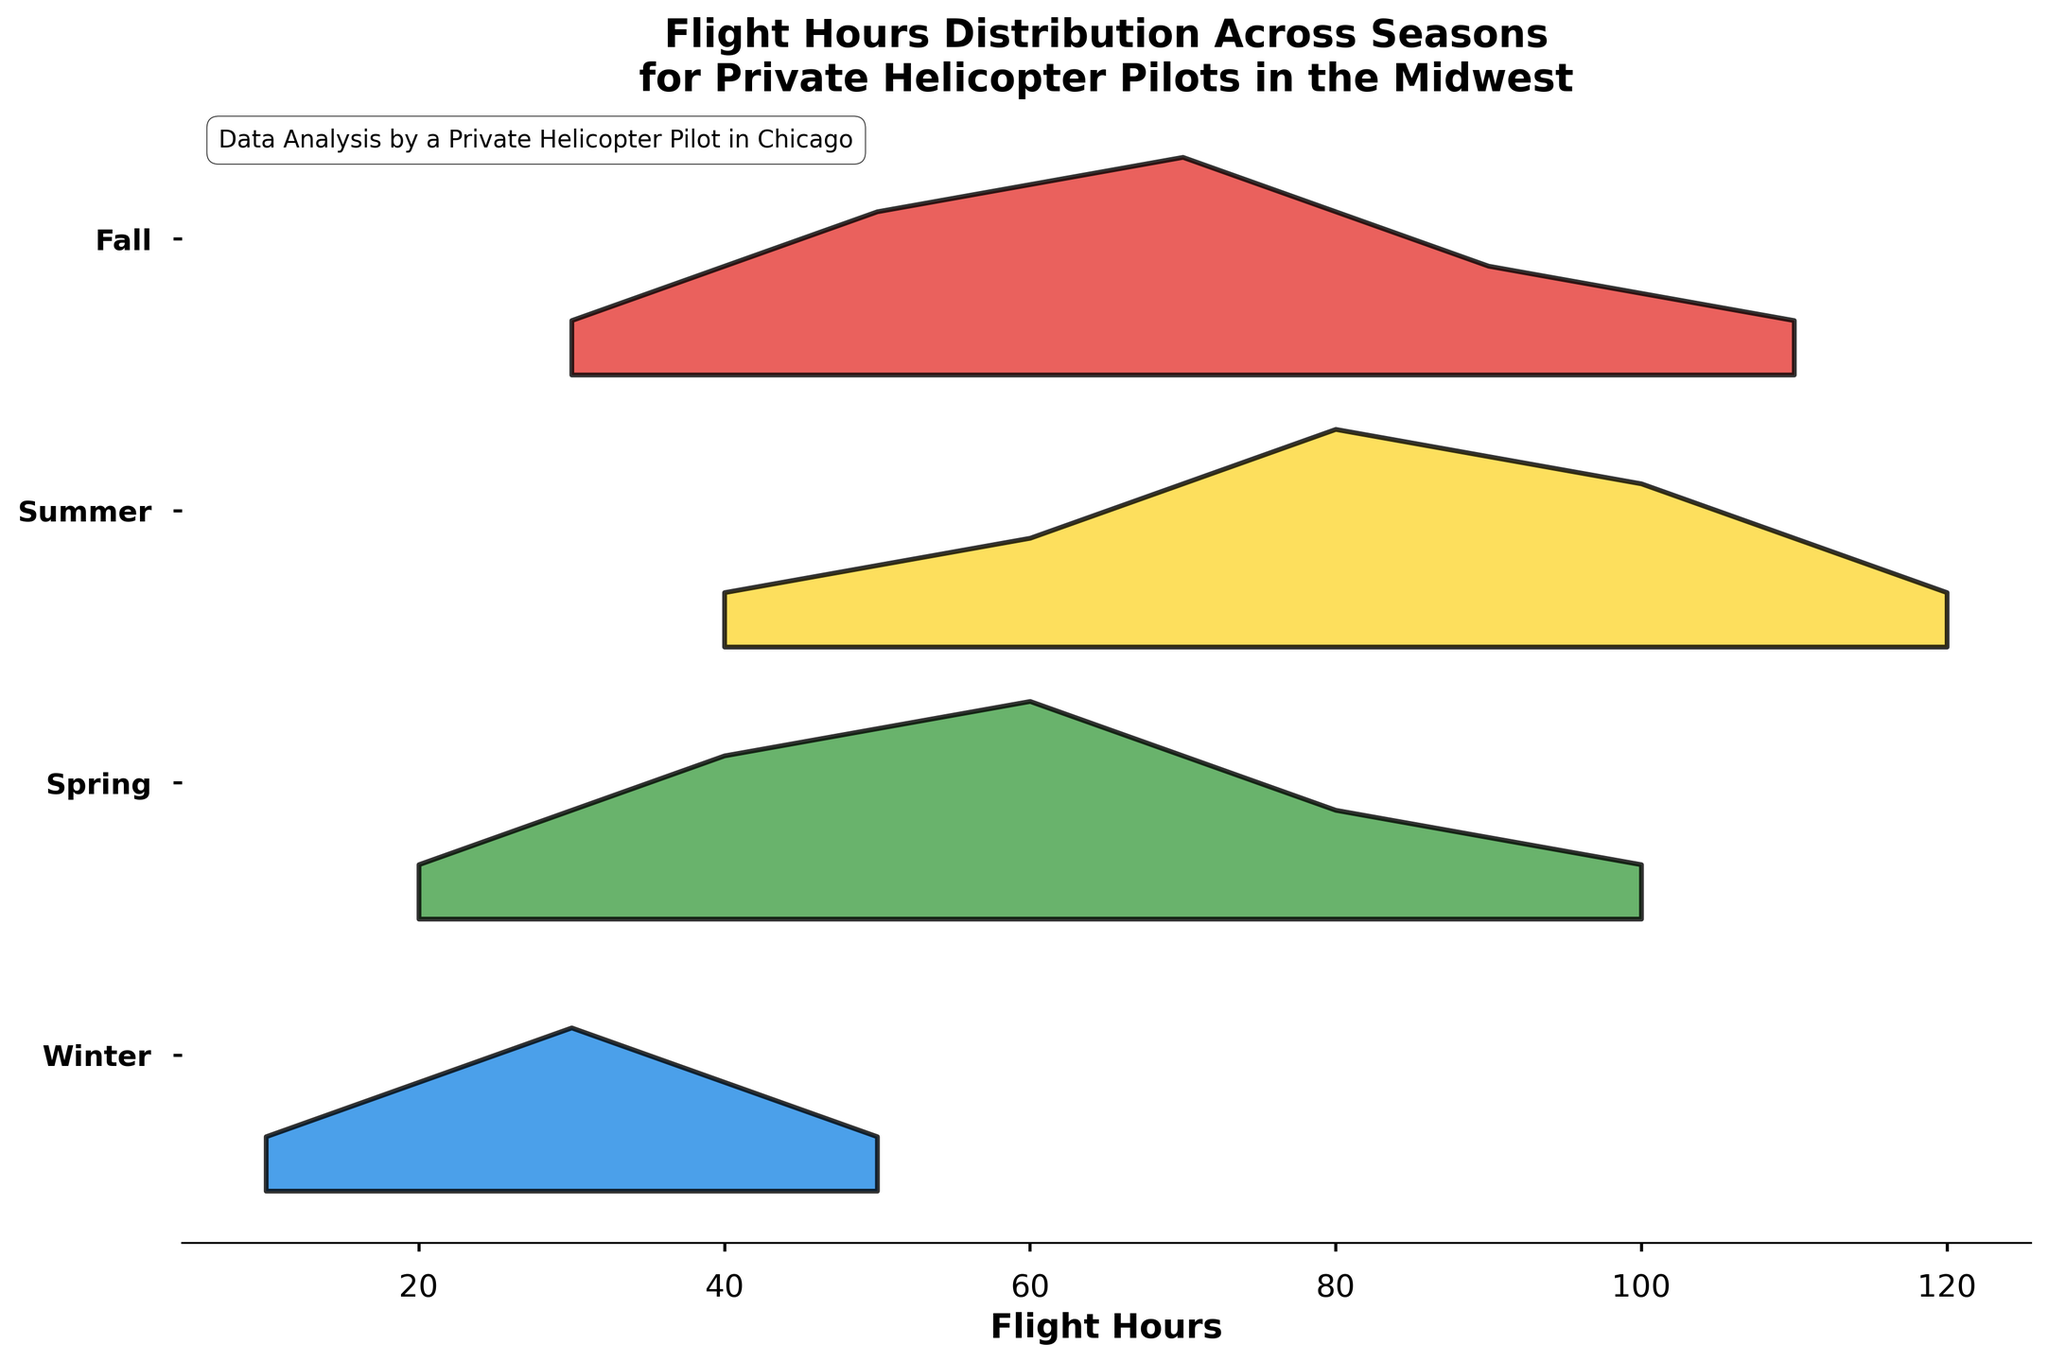What is the title of the figure? The title can be found at the top of the figure, specifying the context and subject of the data displayed.
Answer: Flight Hours Distribution Across Seasons for Private Helicopter Pilots in the Midwest Which season shows the highest density of flight hours around 80? Look at the height of the density curve around the 80-hour mark for each season.
Answer: Summer How many seasons are represented in the plot? Count the number of unique seasons represented on the y-axis.
Answer: 4 During which season do pilots have the lowest flight hours density? Identify the season with the lowest peak density by comparing the heights of the density curves across all seasons.
Answer: Winter What is the range of flight hours displayed in the figure? Check the x-axis to determine the minimum and maximum flight hours shown in the figure.
Answer: 10 to 120 In which season are the flight hours most evenly distributed from 20 to 100 hours? Compare the spread and flatness of the density curves across the seasons within that hour range.
Answer: Spring What's the highest density value for Fall season? Look at the peak of the density curve for Fall to find its highest point on the y-axis.
Answer: 0.04 Compare the density of flight hours at 50 hours between Winter and Fall. Which season shows a higher density? Compare the density values at 50 hours for Winter and Fall by examining the height of the curves at that point.
Answer: Fall Which season has the broadest range of flight hours with notable density? Identify the season where the density curve spans a wider range of hours, by comparing the length and flatness of curves across all seasons.
Answer: Summer In Winter, what are the flight hours corresponding to the highest density? Find the peak of the density curve for Winter and look at the corresponding x-axis (flight hours) value.
Answer: 30 hours Which season has the highest density of flight hours above 100 hours? Observe the density curves above the 100-hour mark and identify which season's curve is highest.
Answer: Summer 